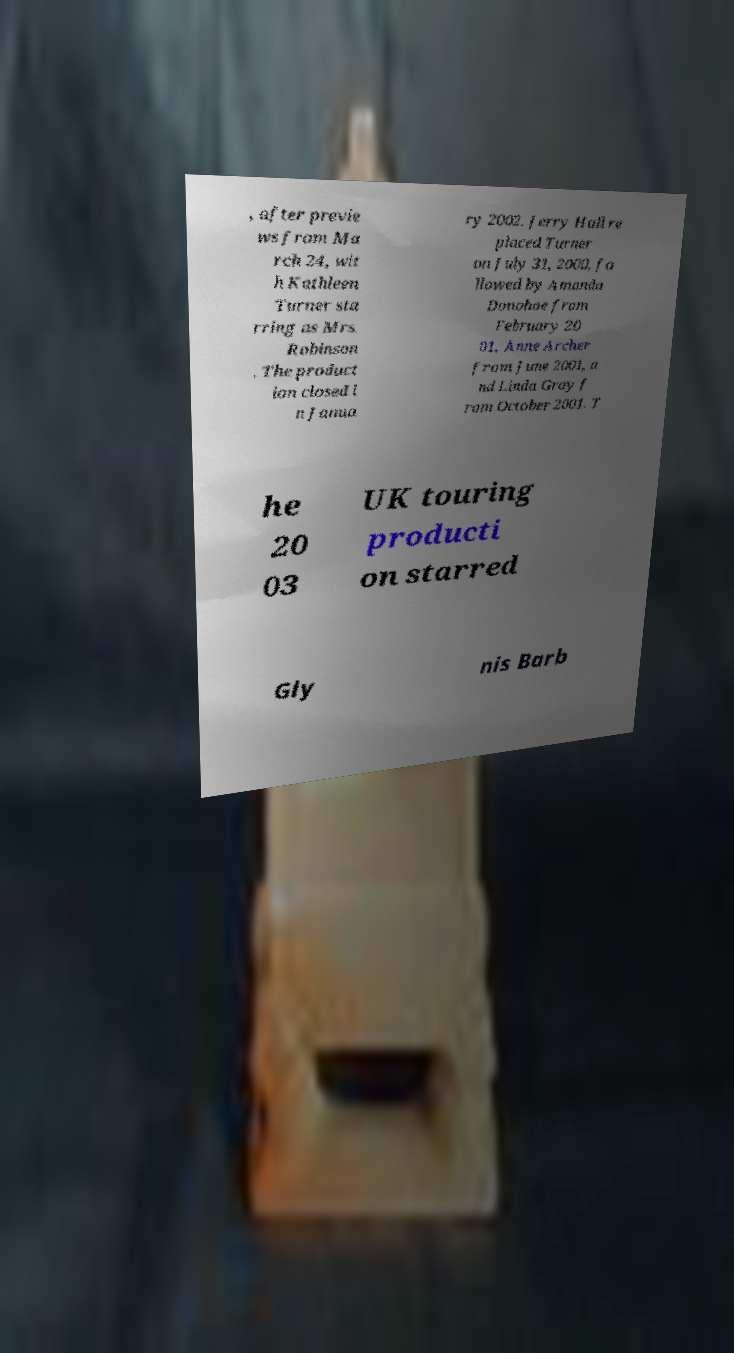Please identify and transcribe the text found in this image. , after previe ws from Ma rch 24, wit h Kathleen Turner sta rring as Mrs. Robinson . The product ion closed i n Janua ry 2002. Jerry Hall re placed Turner on July 31, 2000, fo llowed by Amanda Donohoe from February 20 01, Anne Archer from June 2001, a nd Linda Gray f rom October 2001. T he 20 03 UK touring producti on starred Gly nis Barb 